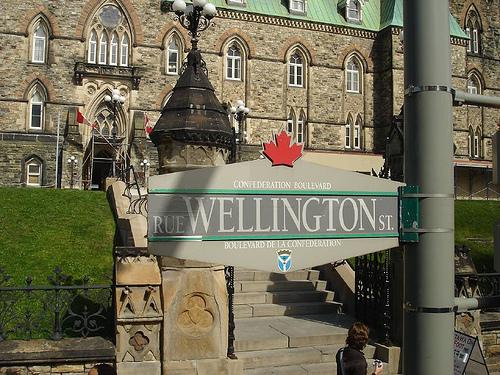What is the name of the street?
Be succinct. Wellington. Which color is dominant?
Be succinct. Brown. What kind of leaf is on top of sign?
Answer briefly. Maple. Is this a street in Canada?
Be succinct. Yes. 